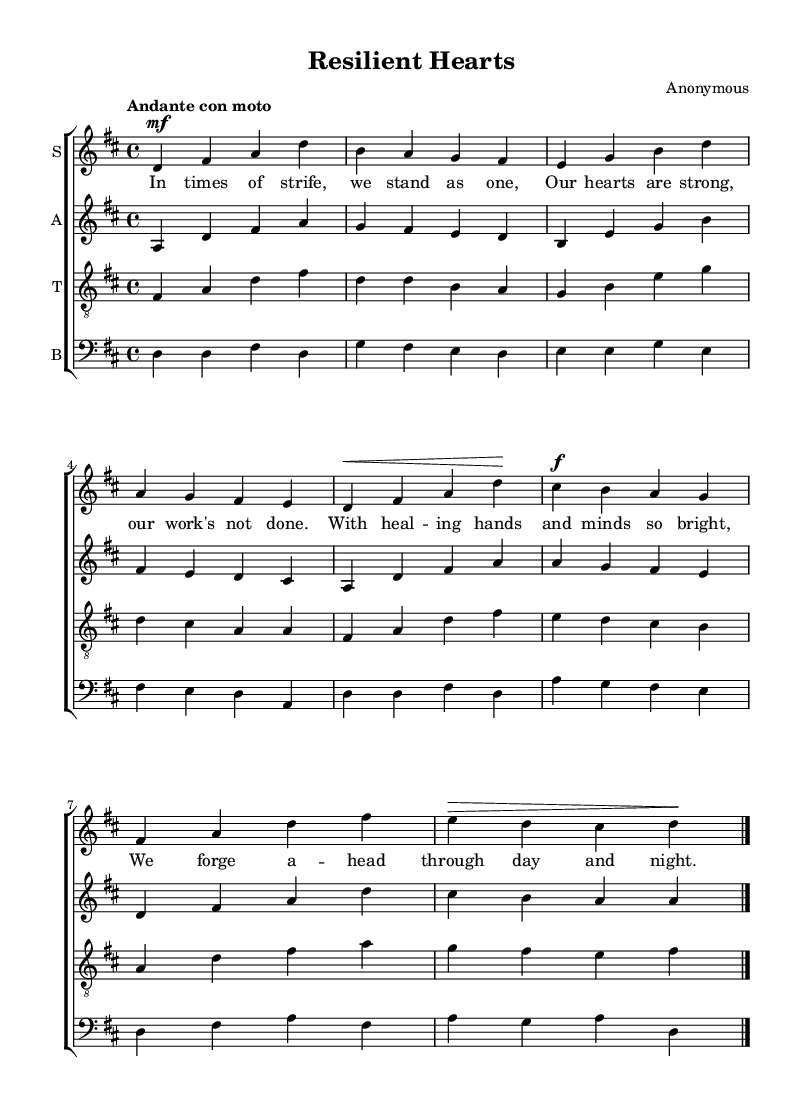What is the key signature of this music? The key signature indicates the notes to be played sharp or flat. In the sheet music, there are two sharps shown, which corresponds to D major.
Answer: D major What is the time signature of this music? The time signature is represented at the beginning of the sheet music; here, it shows 4/4, indicating four beats per measure with the quarter note receiving one beat.
Answer: 4/4 What is the tempo marking for this piece? The tempo marking is provided in Italian, and in this sheet music, it says "Andante con moto," which translates to a moderately slow pace with some movement.
Answer: Andante con moto How many voices are present in this choral arrangement? By observing the score, one can see that there are four distinct voice parts: soprano, alto, tenor, and bass, making up the choir.
Answer: Four Which voice part has the lowest pitch range? The bass voice typically provides the lowest pitch in choral arrangements. Upon examining the clef used for each voice part, the bass clef indicates it has the lowest range.
Answer: Bass What is the text of the first line of the lyrics? The first line of lyrics can be found beneath the soprano staff in the lyrics section, which is "In times of strife, we stand as one."
Answer: In times of strife, we stand as one How is the dynamic marking indicated for the soprano voice? The dynamic marking for the soprano voice is shown by the symbol 'mf' (mezzo-forte) before the first note, indicating a medium loudness.
Answer: mf 